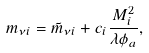<formula> <loc_0><loc_0><loc_500><loc_500>m _ { \nu i } = \tilde { m } _ { \nu i } + c _ { i } \frac { M _ { i } ^ { 2 } } { \lambda \phi _ { a } } ,</formula> 